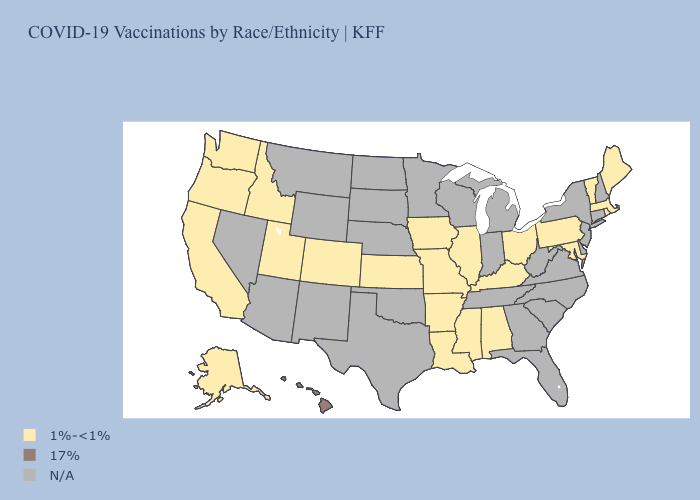Among the states that border Iowa , which have the highest value?
Short answer required. Illinois, Missouri. Does Idaho have the lowest value in the West?
Short answer required. Yes. Name the states that have a value in the range 1%-<1%?
Answer briefly. Alabama, Alaska, Arkansas, California, Colorado, Idaho, Illinois, Iowa, Kansas, Kentucky, Louisiana, Maine, Maryland, Massachusetts, Mississippi, Missouri, Ohio, Oregon, Pennsylvania, Rhode Island, Utah, Vermont, Washington. Which states have the lowest value in the West?
Concise answer only. Alaska, California, Colorado, Idaho, Oregon, Utah, Washington. Among the states that border California , which have the lowest value?
Keep it brief. Oregon. Does Alabama have the lowest value in the USA?
Keep it brief. Yes. What is the lowest value in states that border Ohio?
Answer briefly. 1%-<1%. What is the value of Maine?
Quick response, please. 1%-<1%. What is the value of Maine?
Quick response, please. 1%-<1%. Does Rhode Island have the highest value in the USA?
Quick response, please. No. 